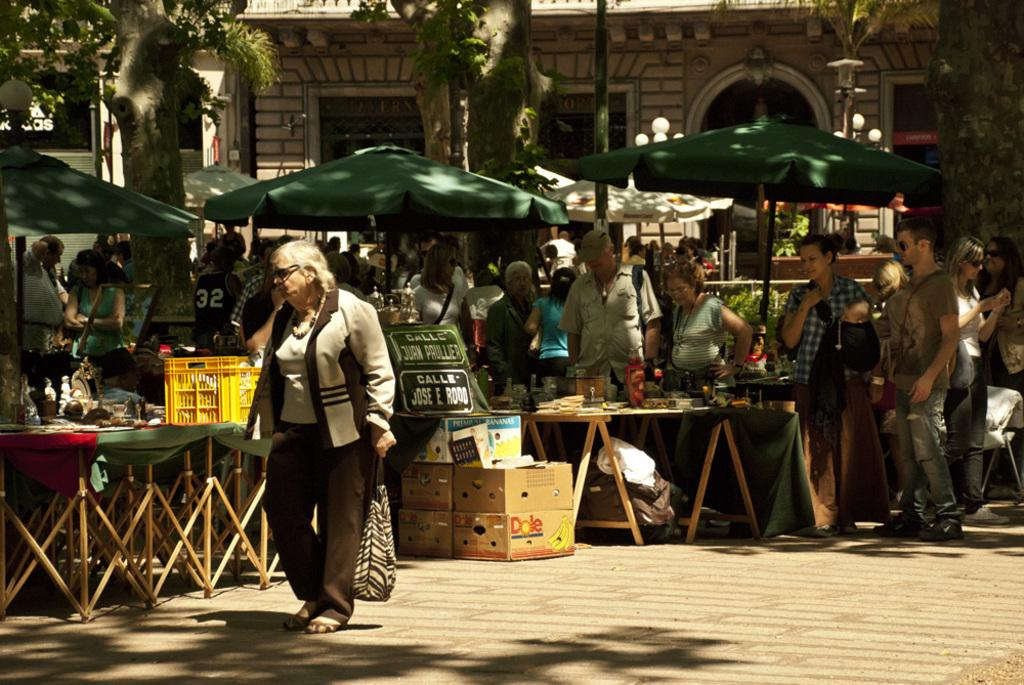<image>
Share a concise interpretation of the image provided. An outdoor market where customers are walking through and a Dole banana box is at one of the vendors. 